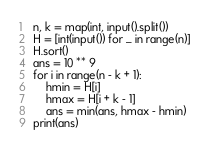<code> <loc_0><loc_0><loc_500><loc_500><_Python_>n, k = map(int, input().split())
H = [int(input()) for _ in range(n)]
H.sort()
ans = 10 ** 9
for i in range(n - k + 1):
    hmin = H[i]
    hmax = H[i + k - 1]
    ans = min(ans, hmax - hmin)
print(ans)</code> 